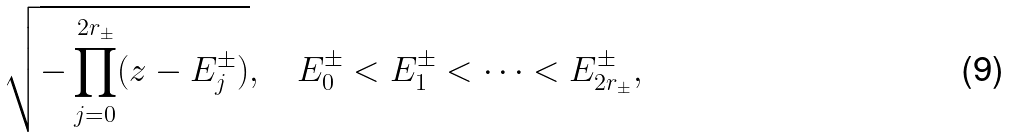Convert formula to latex. <formula><loc_0><loc_0><loc_500><loc_500>\sqrt { - \prod _ { j = 0 } ^ { 2 r _ { \pm } } ( z - E _ { j } ^ { \pm } ) } , \quad E _ { 0 } ^ { \pm } < E _ { 1 } ^ { \pm } < \cdots < E _ { 2 r _ { \pm } } ^ { \pm } ,</formula> 